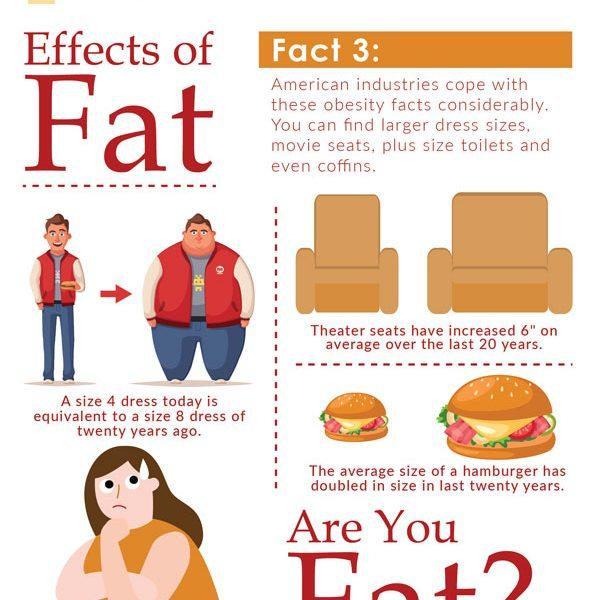Highlight a few significant elements in this photo. The info graphic shows 2 seats. 